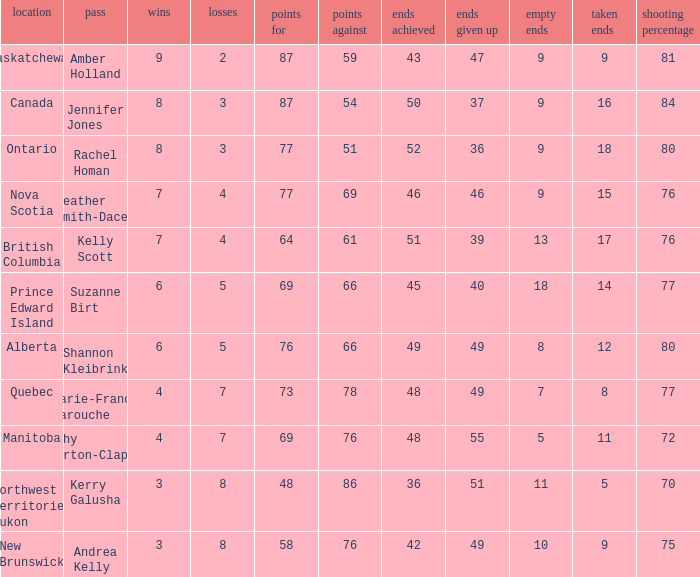If the skip is Kelly Scott, what is the PF total number? 1.0. 